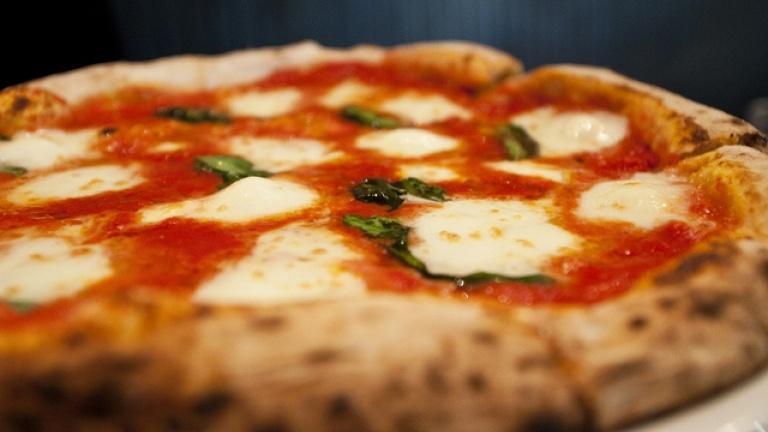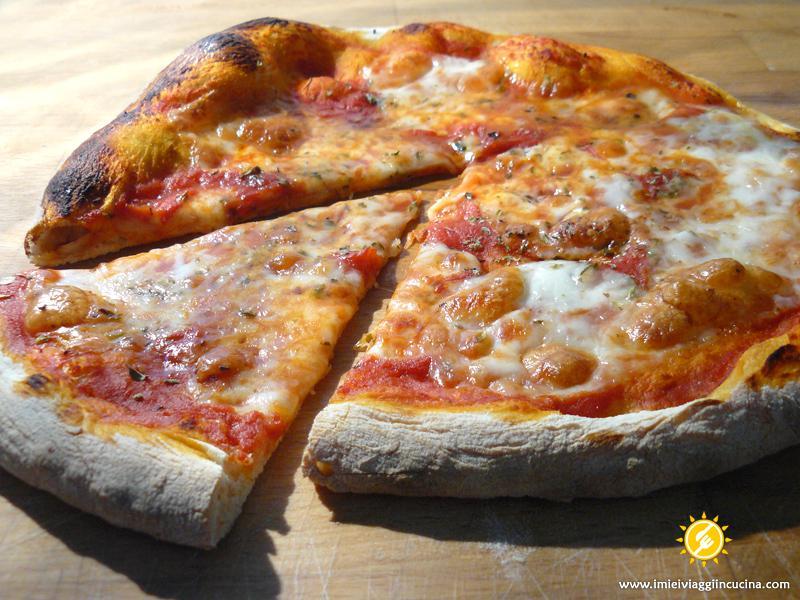The first image is the image on the left, the second image is the image on the right. Assess this claim about the two images: "The right image shows one slice of a round pizza separated by a small distance from the rest.". Correct or not? Answer yes or no. Yes. The first image is the image on the left, the second image is the image on the right. Considering the images on both sides, is "there is a pizza with rounds of mozzarella melted and green bits of basil" valid? Answer yes or no. Yes. 